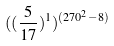<formula> <loc_0><loc_0><loc_500><loc_500>( ( \frac { 5 } { 1 7 } ) ^ { 1 } ) ^ { ( 2 7 0 ^ { 2 } - 8 ) }</formula> 